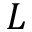<formula> <loc_0><loc_0><loc_500><loc_500>L</formula> 